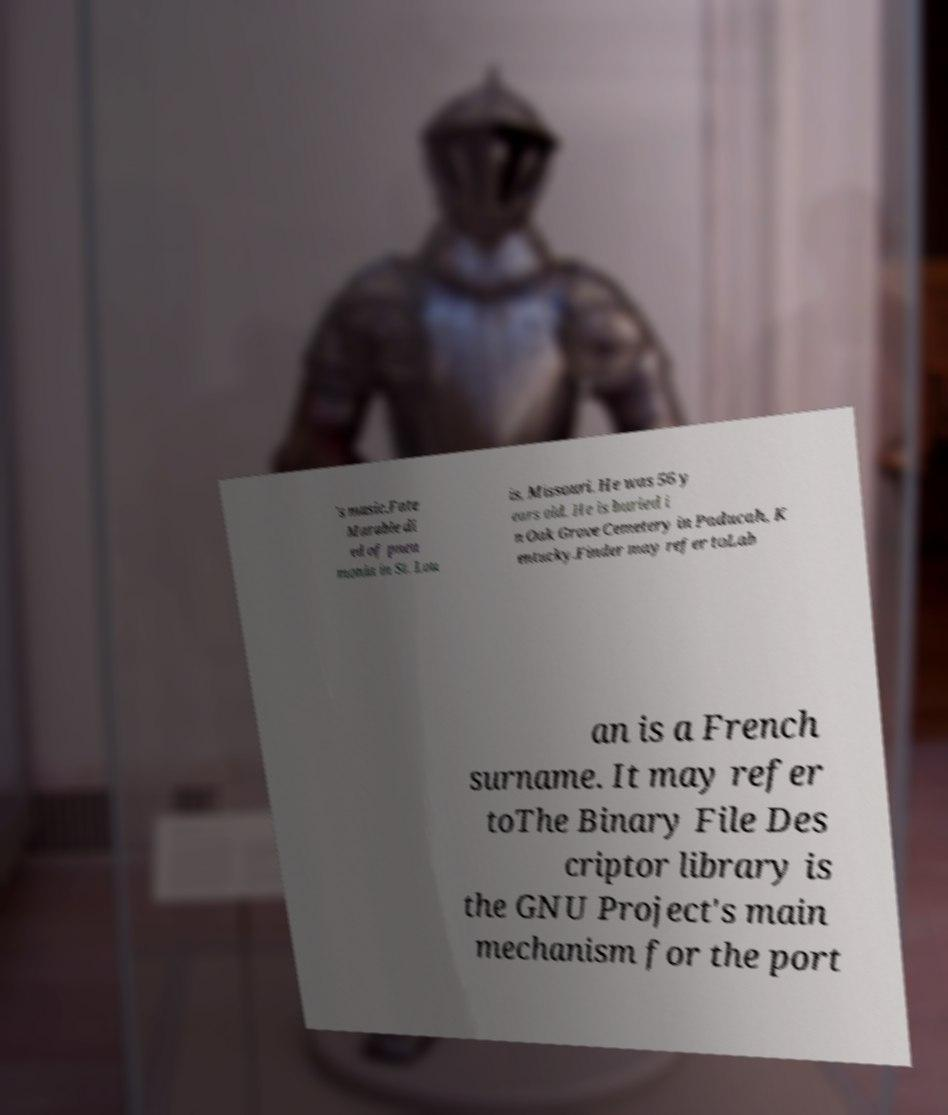Could you assist in decoding the text presented in this image and type it out clearly? 's music.Fate Marable di ed of pneu monia in St. Lou is, Missouri. He was 56 y ears old. He is buried i n Oak Grove Cemetery in Paducah, K entucky.Finder may refer toLab an is a French surname. It may refer toThe Binary File Des criptor library is the GNU Project's main mechanism for the port 